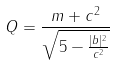Convert formula to latex. <formula><loc_0><loc_0><loc_500><loc_500>Q = \frac { m + c ^ { 2 } } { \sqrt { 5 - \frac { | b | ^ { 2 } } { c ^ { 2 } } } }</formula> 